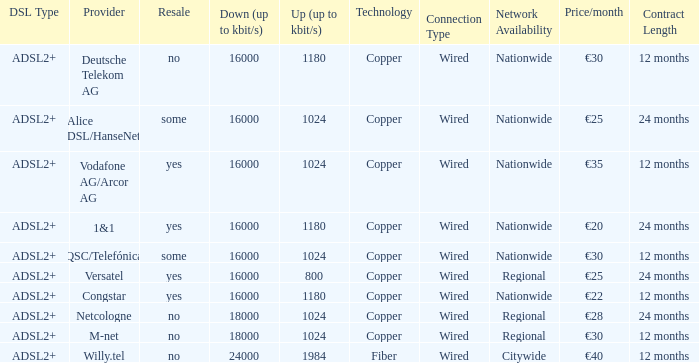Who are all of the telecom providers for which the upload rate is 1024 kbits and the resale category is yes? Vodafone AG/Arcor AG. 